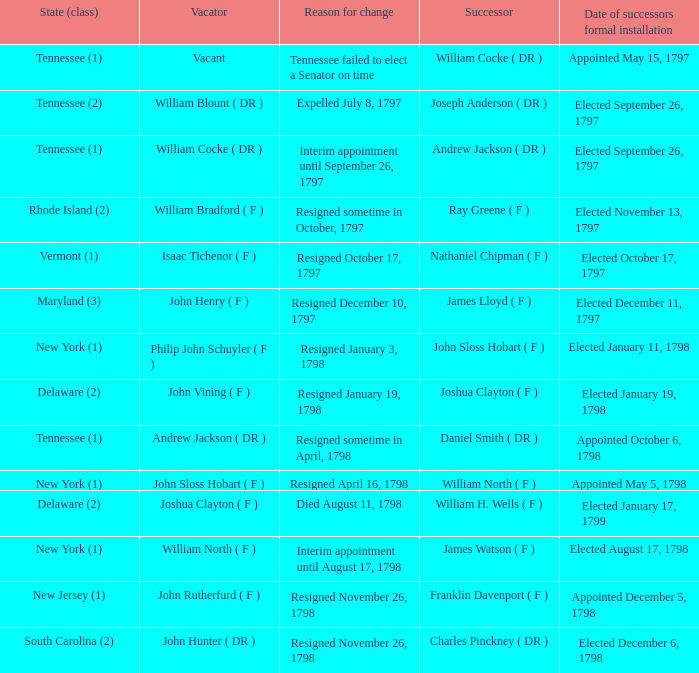Parse the full table. {'header': ['State (class)', 'Vacator', 'Reason for change', 'Successor', 'Date of successors formal installation'], 'rows': [['Tennessee (1)', 'Vacant', 'Tennessee failed to elect a Senator on time', 'William Cocke ( DR )', 'Appointed May 15, 1797'], ['Tennessee (2)', 'William Blount ( DR )', 'Expelled July 8, 1797', 'Joseph Anderson ( DR )', 'Elected September 26, 1797'], ['Tennessee (1)', 'William Cocke ( DR )', 'Interim appointment until September 26, 1797', 'Andrew Jackson ( DR )', 'Elected September 26, 1797'], ['Rhode Island (2)', 'William Bradford ( F )', 'Resigned sometime in October, 1797', 'Ray Greene ( F )', 'Elected November 13, 1797'], ['Vermont (1)', 'Isaac Tichenor ( F )', 'Resigned October 17, 1797', 'Nathaniel Chipman ( F )', 'Elected October 17, 1797'], ['Maryland (3)', 'John Henry ( F )', 'Resigned December 10, 1797', 'James Lloyd ( F )', 'Elected December 11, 1797'], ['New York (1)', 'Philip John Schuyler ( F )', 'Resigned January 3, 1798', 'John Sloss Hobart ( F )', 'Elected January 11, 1798'], ['Delaware (2)', 'John Vining ( F )', 'Resigned January 19, 1798', 'Joshua Clayton ( F )', 'Elected January 19, 1798'], ['Tennessee (1)', 'Andrew Jackson ( DR )', 'Resigned sometime in April, 1798', 'Daniel Smith ( DR )', 'Appointed October 6, 1798'], ['New York (1)', 'John Sloss Hobart ( F )', 'Resigned April 16, 1798', 'William North ( F )', 'Appointed May 5, 1798'], ['Delaware (2)', 'Joshua Clayton ( F )', 'Died August 11, 1798', 'William H. Wells ( F )', 'Elected January 17, 1799'], ['New York (1)', 'William North ( F )', 'Interim appointment until August 17, 1798', 'James Watson ( F )', 'Elected August 17, 1798'], ['New Jersey (1)', 'John Rutherfurd ( F )', 'Resigned November 26, 1798', 'Franklin Davenport ( F )', 'Appointed December 5, 1798'], ['South Carolina (2)', 'John Hunter ( DR )', 'Resigned November 26, 1798', 'Charles Pinckney ( DR )', 'Elected December 6, 1798']]} What are all the states (category) when the successor was joseph anderson (dr)? Tennessee (2). 